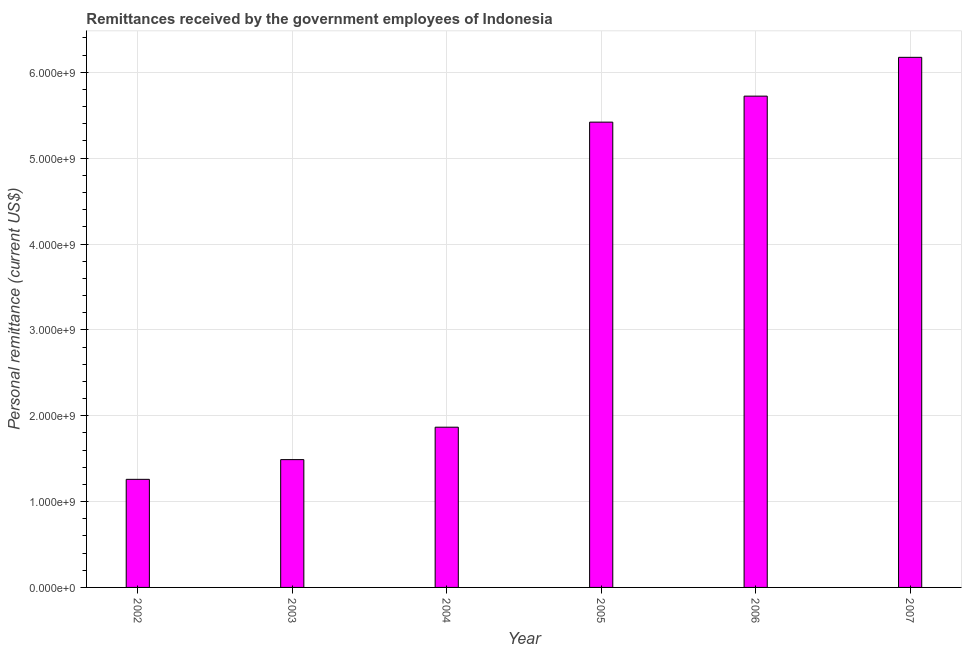Does the graph contain any zero values?
Make the answer very short. No. What is the title of the graph?
Give a very brief answer. Remittances received by the government employees of Indonesia. What is the label or title of the X-axis?
Offer a terse response. Year. What is the label or title of the Y-axis?
Your response must be concise. Personal remittance (current US$). What is the personal remittances in 2005?
Give a very brief answer. 5.42e+09. Across all years, what is the maximum personal remittances?
Offer a terse response. 6.17e+09. Across all years, what is the minimum personal remittances?
Your answer should be very brief. 1.26e+09. What is the sum of the personal remittances?
Offer a terse response. 2.19e+1. What is the difference between the personal remittances in 2002 and 2004?
Give a very brief answer. -6.07e+08. What is the average personal remittances per year?
Offer a very short reply. 3.66e+09. What is the median personal remittances?
Offer a terse response. 3.64e+09. Do a majority of the years between 2003 and 2004 (inclusive) have personal remittances greater than 5000000000 US$?
Offer a very short reply. No. What is the ratio of the personal remittances in 2002 to that in 2007?
Keep it short and to the point. 0.2. Is the personal remittances in 2005 less than that in 2007?
Ensure brevity in your answer.  Yes. What is the difference between the highest and the second highest personal remittances?
Your answer should be very brief. 4.52e+08. What is the difference between the highest and the lowest personal remittances?
Provide a short and direct response. 4.92e+09. In how many years, is the personal remittances greater than the average personal remittances taken over all years?
Offer a terse response. 3. Are all the bars in the graph horizontal?
Keep it short and to the point. No. How many years are there in the graph?
Your answer should be compact. 6. What is the Personal remittance (current US$) of 2002?
Provide a succinct answer. 1.26e+09. What is the Personal remittance (current US$) of 2003?
Offer a very short reply. 1.49e+09. What is the Personal remittance (current US$) in 2004?
Give a very brief answer. 1.87e+09. What is the Personal remittance (current US$) of 2005?
Your answer should be compact. 5.42e+09. What is the Personal remittance (current US$) in 2006?
Your response must be concise. 5.72e+09. What is the Personal remittance (current US$) in 2007?
Your answer should be very brief. 6.17e+09. What is the difference between the Personal remittance (current US$) in 2002 and 2003?
Provide a short and direct response. -2.30e+08. What is the difference between the Personal remittance (current US$) in 2002 and 2004?
Provide a short and direct response. -6.07e+08. What is the difference between the Personal remittance (current US$) in 2002 and 2005?
Give a very brief answer. -4.16e+09. What is the difference between the Personal remittance (current US$) in 2002 and 2006?
Your answer should be very brief. -4.46e+09. What is the difference between the Personal remittance (current US$) in 2002 and 2007?
Provide a short and direct response. -4.92e+09. What is the difference between the Personal remittance (current US$) in 2003 and 2004?
Your answer should be very brief. -3.78e+08. What is the difference between the Personal remittance (current US$) in 2003 and 2005?
Give a very brief answer. -3.93e+09. What is the difference between the Personal remittance (current US$) in 2003 and 2006?
Your answer should be compact. -4.23e+09. What is the difference between the Personal remittance (current US$) in 2003 and 2007?
Your answer should be compact. -4.69e+09. What is the difference between the Personal remittance (current US$) in 2004 and 2005?
Ensure brevity in your answer.  -3.55e+09. What is the difference between the Personal remittance (current US$) in 2004 and 2006?
Your answer should be compact. -3.86e+09. What is the difference between the Personal remittance (current US$) in 2004 and 2007?
Provide a short and direct response. -4.31e+09. What is the difference between the Personal remittance (current US$) in 2005 and 2006?
Ensure brevity in your answer.  -3.03e+08. What is the difference between the Personal remittance (current US$) in 2005 and 2007?
Give a very brief answer. -7.55e+08. What is the difference between the Personal remittance (current US$) in 2006 and 2007?
Keep it short and to the point. -4.52e+08. What is the ratio of the Personal remittance (current US$) in 2002 to that in 2003?
Keep it short and to the point. 0.85. What is the ratio of the Personal remittance (current US$) in 2002 to that in 2004?
Your response must be concise. 0.68. What is the ratio of the Personal remittance (current US$) in 2002 to that in 2005?
Offer a very short reply. 0.23. What is the ratio of the Personal remittance (current US$) in 2002 to that in 2006?
Offer a terse response. 0.22. What is the ratio of the Personal remittance (current US$) in 2002 to that in 2007?
Make the answer very short. 0.2. What is the ratio of the Personal remittance (current US$) in 2003 to that in 2004?
Provide a succinct answer. 0.8. What is the ratio of the Personal remittance (current US$) in 2003 to that in 2005?
Offer a terse response. 0.28. What is the ratio of the Personal remittance (current US$) in 2003 to that in 2006?
Keep it short and to the point. 0.26. What is the ratio of the Personal remittance (current US$) in 2003 to that in 2007?
Make the answer very short. 0.24. What is the ratio of the Personal remittance (current US$) in 2004 to that in 2005?
Ensure brevity in your answer.  0.34. What is the ratio of the Personal remittance (current US$) in 2004 to that in 2006?
Your response must be concise. 0.33. What is the ratio of the Personal remittance (current US$) in 2004 to that in 2007?
Offer a terse response. 0.3. What is the ratio of the Personal remittance (current US$) in 2005 to that in 2006?
Your response must be concise. 0.95. What is the ratio of the Personal remittance (current US$) in 2005 to that in 2007?
Offer a very short reply. 0.88. What is the ratio of the Personal remittance (current US$) in 2006 to that in 2007?
Give a very brief answer. 0.93. 